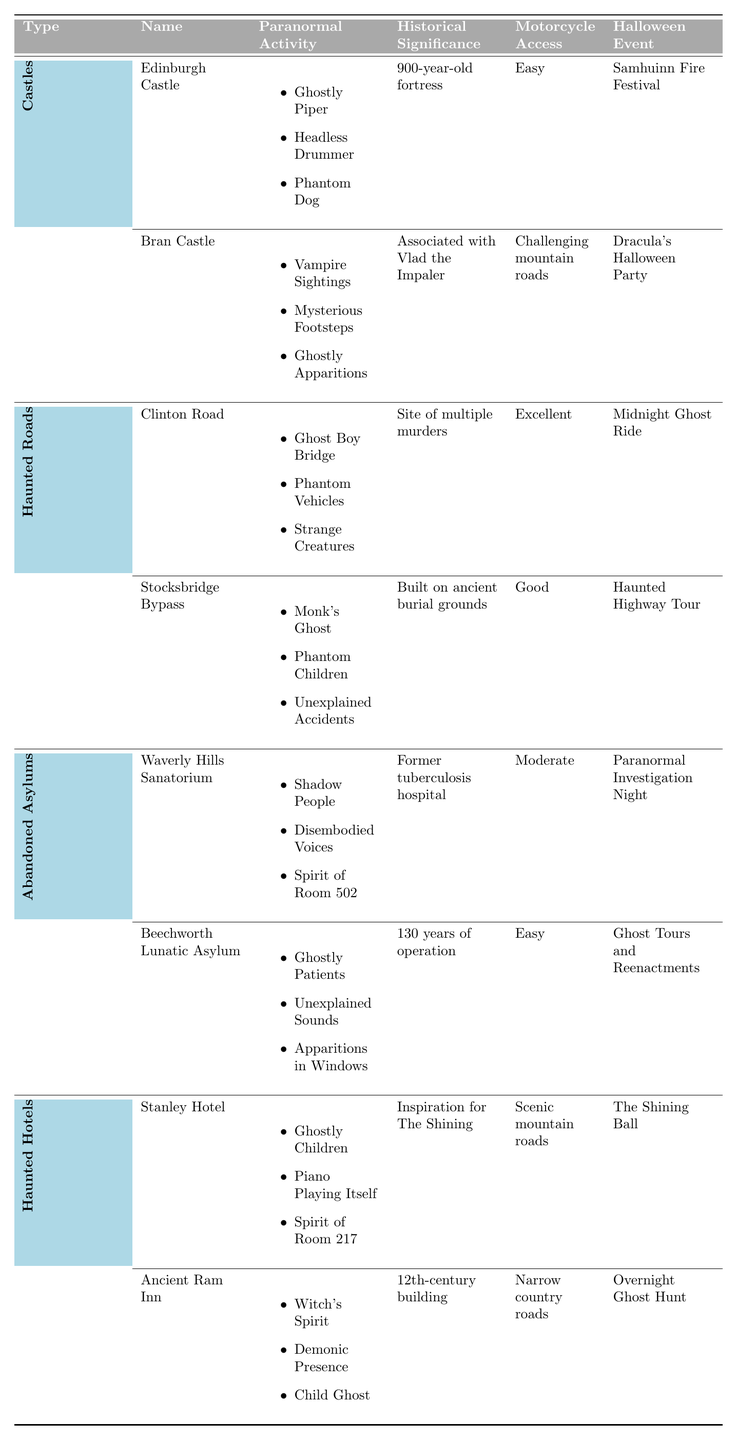What type of paranormal activity is associated with Bran Castle? The table lists the paranormal activities for Bran Castle under the "Paranormal Activity" column. They include "Vampire Sightings," "Mysterious Footsteps," and "Ghostly Apparitions."
Answer: Vampire Sightings, Mysterious Footsteps, Ghostly Apparitions Which haunted location has challenging motorcycle access? Looking in the "Motorcycle Access" column, both Bran Castle and Stocksbridge Bypass mention challenging access, but since we are only looking for one instance, we notice that Bran Castle specifically mentions "Challenging mountain roads."
Answer: Bran Castle How many haunted hotels are listed in the table? By examining the table, there are two entries under the "Haunted Hotels" category: the Stanley Hotel and Ancient Ram Inn. Therefore, the total count is 2.
Answer: 2 Is the Waverly Hills Sanatorium known for its connection to tuberculosis? The "Historical Significance" column for Waverly Hills Sanatorium states that it was a former tuberculosis hospital, confirming its connection to tuberculosis.
Answer: Yes Which haunted location has the easiest motorcycle access? In the "Motorcycle Access" column, both Edinburgh Castle and Beechworth Lunatic Asylum are labeled as "Easy." However, since we only need one, we can mention Edinburgh Castle since it appears first.
Answer: Edinburgh Castle What are the Halloween events associated with haunted roads? The table lists two haunted roads: Clinton Road with "Midnight Ghost Ride" and Stocksbridge Bypass with "Haunted Highway Tour." Thus, the Halloween events for haunted roads are those two.
Answer: Midnight Ghost Ride, Haunted Highway Tour Which type of haunted location is associated with "Spirit of Room 502"? We look in the "Paranormal Activity" column and find that "Spirit of Room 502" is listed only for Waverly Hills Sanatorium. Therefore, it is related to abandoned asylums.
Answer: Abandoned Asylums How many different types of paranormal activities are listed for the Stanley Hotel? The table indicates three paranormal activities for the Stanley Hotel: "Ghostly Children," "Piano Playing Itself," and "Spirit of Room 217," giving a total of 3 different types.
Answer: 3 Is it true that the Ancient Ram Inn is known for a witch's spirit? The table states that one of the paranormal activities at the Ancient Ram Inn is the "Witch's Spirit," confirming this fact.
Answer: True What is the historical significance of the Stocksbridge Bypass? By looking at the "Historical Significance" column, it indicates that the Stocksbridge Bypass was built on ancient burial grounds. Therefore, this is its historical significance.
Answer: Built on ancient burial grounds 